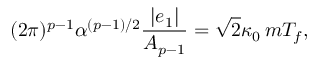<formula> <loc_0><loc_0><loc_500><loc_500>( 2 \pi ) ^ { p - 1 } \alpha ^ { ( p - 1 ) / 2 } \frac { | e _ { 1 } | } { A _ { p - 1 } } = \sqrt { 2 } \kappa _ { 0 } \, m T _ { f } ,</formula> 